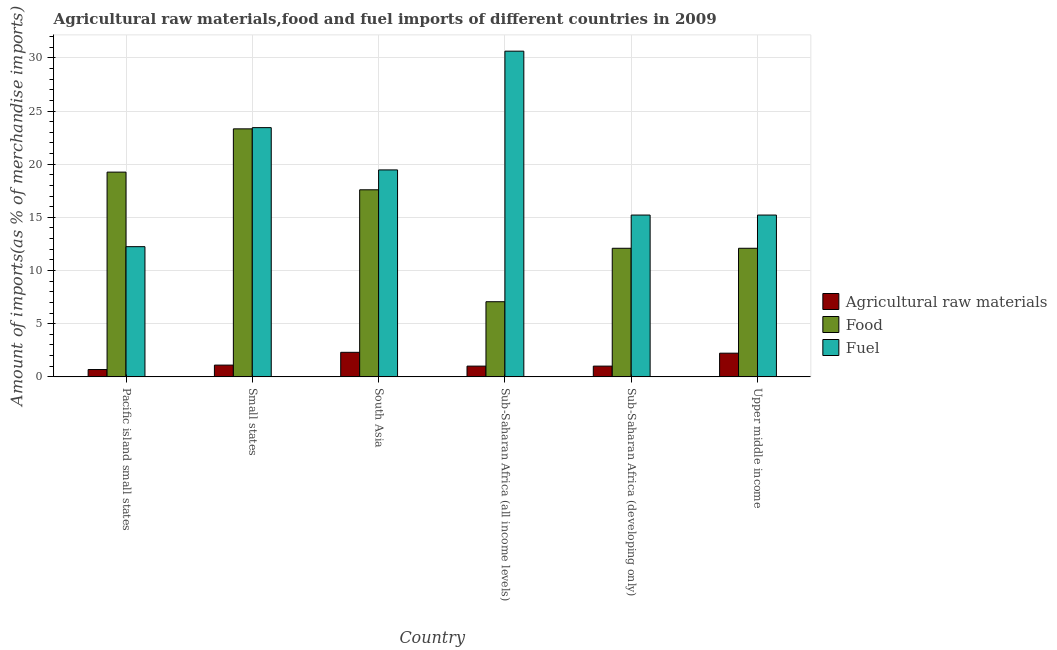How many groups of bars are there?
Offer a very short reply. 6. Are the number of bars per tick equal to the number of legend labels?
Ensure brevity in your answer.  Yes. How many bars are there on the 4th tick from the right?
Make the answer very short. 3. What is the label of the 5th group of bars from the left?
Your answer should be very brief. Sub-Saharan Africa (developing only). In how many cases, is the number of bars for a given country not equal to the number of legend labels?
Make the answer very short. 0. What is the percentage of fuel imports in Small states?
Provide a succinct answer. 23.44. Across all countries, what is the maximum percentage of fuel imports?
Your response must be concise. 30.63. Across all countries, what is the minimum percentage of fuel imports?
Keep it short and to the point. 12.24. In which country was the percentage of fuel imports maximum?
Provide a succinct answer. Sub-Saharan Africa (all income levels). In which country was the percentage of raw materials imports minimum?
Ensure brevity in your answer.  Pacific island small states. What is the total percentage of raw materials imports in the graph?
Your answer should be compact. 8.35. What is the difference between the percentage of fuel imports in Small states and that in South Asia?
Make the answer very short. 3.98. What is the difference between the percentage of raw materials imports in Small states and the percentage of food imports in Sub-Saharan Africa (developing only)?
Keep it short and to the point. -10.99. What is the average percentage of raw materials imports per country?
Provide a short and direct response. 1.39. What is the difference between the percentage of raw materials imports and percentage of food imports in Upper middle income?
Keep it short and to the point. -9.87. In how many countries, is the percentage of fuel imports greater than 24 %?
Your answer should be compact. 1. What is the ratio of the percentage of food imports in Pacific island small states to that in Upper middle income?
Give a very brief answer. 1.59. Is the percentage of food imports in Small states less than that in Sub-Saharan Africa (all income levels)?
Your response must be concise. No. Is the difference between the percentage of raw materials imports in Small states and Sub-Saharan Africa (all income levels) greater than the difference between the percentage of food imports in Small states and Sub-Saharan Africa (all income levels)?
Ensure brevity in your answer.  No. What is the difference between the highest and the second highest percentage of fuel imports?
Provide a succinct answer. 7.19. What is the difference between the highest and the lowest percentage of fuel imports?
Provide a short and direct response. 18.38. What does the 3rd bar from the left in Small states represents?
Your answer should be very brief. Fuel. What does the 2nd bar from the right in Pacific island small states represents?
Provide a succinct answer. Food. Are all the bars in the graph horizontal?
Offer a terse response. No. Are the values on the major ticks of Y-axis written in scientific E-notation?
Make the answer very short. No. Does the graph contain any zero values?
Ensure brevity in your answer.  No. Where does the legend appear in the graph?
Make the answer very short. Center right. How many legend labels are there?
Offer a very short reply. 3. How are the legend labels stacked?
Your response must be concise. Vertical. What is the title of the graph?
Ensure brevity in your answer.  Agricultural raw materials,food and fuel imports of different countries in 2009. Does "Manufactures" appear as one of the legend labels in the graph?
Your response must be concise. No. What is the label or title of the X-axis?
Ensure brevity in your answer.  Country. What is the label or title of the Y-axis?
Your response must be concise. Amount of imports(as % of merchandise imports). What is the Amount of imports(as % of merchandise imports) in Agricultural raw materials in Pacific island small states?
Your answer should be very brief. 0.69. What is the Amount of imports(as % of merchandise imports) of Food in Pacific island small states?
Offer a terse response. 19.25. What is the Amount of imports(as % of merchandise imports) in Fuel in Pacific island small states?
Provide a succinct answer. 12.24. What is the Amount of imports(as % of merchandise imports) of Agricultural raw materials in Small states?
Keep it short and to the point. 1.11. What is the Amount of imports(as % of merchandise imports) of Food in Small states?
Give a very brief answer. 23.32. What is the Amount of imports(as % of merchandise imports) in Fuel in Small states?
Keep it short and to the point. 23.44. What is the Amount of imports(as % of merchandise imports) in Agricultural raw materials in South Asia?
Your answer should be very brief. 2.31. What is the Amount of imports(as % of merchandise imports) in Food in South Asia?
Your answer should be very brief. 17.59. What is the Amount of imports(as % of merchandise imports) of Fuel in South Asia?
Your response must be concise. 19.46. What is the Amount of imports(as % of merchandise imports) of Agricultural raw materials in Sub-Saharan Africa (all income levels)?
Offer a very short reply. 1.01. What is the Amount of imports(as % of merchandise imports) in Food in Sub-Saharan Africa (all income levels)?
Provide a short and direct response. 7.07. What is the Amount of imports(as % of merchandise imports) in Fuel in Sub-Saharan Africa (all income levels)?
Keep it short and to the point. 30.63. What is the Amount of imports(as % of merchandise imports) in Agricultural raw materials in Sub-Saharan Africa (developing only)?
Offer a terse response. 1.01. What is the Amount of imports(as % of merchandise imports) in Food in Sub-Saharan Africa (developing only)?
Make the answer very short. 12.09. What is the Amount of imports(as % of merchandise imports) in Fuel in Sub-Saharan Africa (developing only)?
Your answer should be very brief. 15.22. What is the Amount of imports(as % of merchandise imports) in Agricultural raw materials in Upper middle income?
Offer a very short reply. 2.23. What is the Amount of imports(as % of merchandise imports) in Food in Upper middle income?
Your response must be concise. 12.09. What is the Amount of imports(as % of merchandise imports) in Fuel in Upper middle income?
Offer a very short reply. 15.22. Across all countries, what is the maximum Amount of imports(as % of merchandise imports) of Agricultural raw materials?
Your answer should be compact. 2.31. Across all countries, what is the maximum Amount of imports(as % of merchandise imports) of Food?
Your answer should be very brief. 23.32. Across all countries, what is the maximum Amount of imports(as % of merchandise imports) in Fuel?
Provide a short and direct response. 30.63. Across all countries, what is the minimum Amount of imports(as % of merchandise imports) of Agricultural raw materials?
Give a very brief answer. 0.69. Across all countries, what is the minimum Amount of imports(as % of merchandise imports) of Food?
Provide a succinct answer. 7.07. Across all countries, what is the minimum Amount of imports(as % of merchandise imports) of Fuel?
Give a very brief answer. 12.24. What is the total Amount of imports(as % of merchandise imports) in Agricultural raw materials in the graph?
Keep it short and to the point. 8.35. What is the total Amount of imports(as % of merchandise imports) in Food in the graph?
Make the answer very short. 91.42. What is the total Amount of imports(as % of merchandise imports) in Fuel in the graph?
Your response must be concise. 116.2. What is the difference between the Amount of imports(as % of merchandise imports) in Agricultural raw materials in Pacific island small states and that in Small states?
Your response must be concise. -0.42. What is the difference between the Amount of imports(as % of merchandise imports) of Food in Pacific island small states and that in Small states?
Give a very brief answer. -4.07. What is the difference between the Amount of imports(as % of merchandise imports) in Fuel in Pacific island small states and that in Small states?
Your answer should be very brief. -11.19. What is the difference between the Amount of imports(as % of merchandise imports) in Agricultural raw materials in Pacific island small states and that in South Asia?
Give a very brief answer. -1.62. What is the difference between the Amount of imports(as % of merchandise imports) in Food in Pacific island small states and that in South Asia?
Make the answer very short. 1.66. What is the difference between the Amount of imports(as % of merchandise imports) in Fuel in Pacific island small states and that in South Asia?
Make the answer very short. -7.22. What is the difference between the Amount of imports(as % of merchandise imports) of Agricultural raw materials in Pacific island small states and that in Sub-Saharan Africa (all income levels)?
Your response must be concise. -0.32. What is the difference between the Amount of imports(as % of merchandise imports) of Food in Pacific island small states and that in Sub-Saharan Africa (all income levels)?
Make the answer very short. 12.19. What is the difference between the Amount of imports(as % of merchandise imports) of Fuel in Pacific island small states and that in Sub-Saharan Africa (all income levels)?
Provide a short and direct response. -18.38. What is the difference between the Amount of imports(as % of merchandise imports) of Agricultural raw materials in Pacific island small states and that in Sub-Saharan Africa (developing only)?
Give a very brief answer. -0.32. What is the difference between the Amount of imports(as % of merchandise imports) in Food in Pacific island small states and that in Sub-Saharan Africa (developing only)?
Keep it short and to the point. 7.16. What is the difference between the Amount of imports(as % of merchandise imports) of Fuel in Pacific island small states and that in Sub-Saharan Africa (developing only)?
Give a very brief answer. -2.97. What is the difference between the Amount of imports(as % of merchandise imports) of Agricultural raw materials in Pacific island small states and that in Upper middle income?
Keep it short and to the point. -1.54. What is the difference between the Amount of imports(as % of merchandise imports) of Food in Pacific island small states and that in Upper middle income?
Make the answer very short. 7.16. What is the difference between the Amount of imports(as % of merchandise imports) of Fuel in Pacific island small states and that in Upper middle income?
Give a very brief answer. -2.97. What is the difference between the Amount of imports(as % of merchandise imports) in Agricultural raw materials in Small states and that in South Asia?
Offer a terse response. -1.2. What is the difference between the Amount of imports(as % of merchandise imports) in Food in Small states and that in South Asia?
Your answer should be compact. 5.73. What is the difference between the Amount of imports(as % of merchandise imports) in Fuel in Small states and that in South Asia?
Ensure brevity in your answer.  3.98. What is the difference between the Amount of imports(as % of merchandise imports) in Agricultural raw materials in Small states and that in Sub-Saharan Africa (all income levels)?
Provide a succinct answer. 0.1. What is the difference between the Amount of imports(as % of merchandise imports) in Food in Small states and that in Sub-Saharan Africa (all income levels)?
Provide a short and direct response. 16.26. What is the difference between the Amount of imports(as % of merchandise imports) of Fuel in Small states and that in Sub-Saharan Africa (all income levels)?
Your answer should be compact. -7.19. What is the difference between the Amount of imports(as % of merchandise imports) in Agricultural raw materials in Small states and that in Sub-Saharan Africa (developing only)?
Offer a very short reply. 0.1. What is the difference between the Amount of imports(as % of merchandise imports) of Food in Small states and that in Sub-Saharan Africa (developing only)?
Your response must be concise. 11.23. What is the difference between the Amount of imports(as % of merchandise imports) in Fuel in Small states and that in Sub-Saharan Africa (developing only)?
Make the answer very short. 8.22. What is the difference between the Amount of imports(as % of merchandise imports) of Agricultural raw materials in Small states and that in Upper middle income?
Make the answer very short. -1.12. What is the difference between the Amount of imports(as % of merchandise imports) in Food in Small states and that in Upper middle income?
Your answer should be compact. 11.23. What is the difference between the Amount of imports(as % of merchandise imports) in Fuel in Small states and that in Upper middle income?
Your response must be concise. 8.22. What is the difference between the Amount of imports(as % of merchandise imports) of Agricultural raw materials in South Asia and that in Sub-Saharan Africa (all income levels)?
Provide a short and direct response. 1.3. What is the difference between the Amount of imports(as % of merchandise imports) of Food in South Asia and that in Sub-Saharan Africa (all income levels)?
Give a very brief answer. 10.53. What is the difference between the Amount of imports(as % of merchandise imports) in Fuel in South Asia and that in Sub-Saharan Africa (all income levels)?
Ensure brevity in your answer.  -11.17. What is the difference between the Amount of imports(as % of merchandise imports) of Agricultural raw materials in South Asia and that in Sub-Saharan Africa (developing only)?
Offer a terse response. 1.3. What is the difference between the Amount of imports(as % of merchandise imports) of Food in South Asia and that in Sub-Saharan Africa (developing only)?
Make the answer very short. 5.5. What is the difference between the Amount of imports(as % of merchandise imports) of Fuel in South Asia and that in Sub-Saharan Africa (developing only)?
Your response must be concise. 4.25. What is the difference between the Amount of imports(as % of merchandise imports) of Agricultural raw materials in South Asia and that in Upper middle income?
Provide a succinct answer. 0.08. What is the difference between the Amount of imports(as % of merchandise imports) of Food in South Asia and that in Upper middle income?
Your response must be concise. 5.5. What is the difference between the Amount of imports(as % of merchandise imports) of Fuel in South Asia and that in Upper middle income?
Make the answer very short. 4.25. What is the difference between the Amount of imports(as % of merchandise imports) in Agricultural raw materials in Sub-Saharan Africa (all income levels) and that in Sub-Saharan Africa (developing only)?
Provide a short and direct response. 0. What is the difference between the Amount of imports(as % of merchandise imports) in Food in Sub-Saharan Africa (all income levels) and that in Sub-Saharan Africa (developing only)?
Keep it short and to the point. -5.03. What is the difference between the Amount of imports(as % of merchandise imports) of Fuel in Sub-Saharan Africa (all income levels) and that in Sub-Saharan Africa (developing only)?
Give a very brief answer. 15.41. What is the difference between the Amount of imports(as % of merchandise imports) of Agricultural raw materials in Sub-Saharan Africa (all income levels) and that in Upper middle income?
Your answer should be very brief. -1.22. What is the difference between the Amount of imports(as % of merchandise imports) of Food in Sub-Saharan Africa (all income levels) and that in Upper middle income?
Offer a terse response. -5.03. What is the difference between the Amount of imports(as % of merchandise imports) in Fuel in Sub-Saharan Africa (all income levels) and that in Upper middle income?
Give a very brief answer. 15.41. What is the difference between the Amount of imports(as % of merchandise imports) of Agricultural raw materials in Sub-Saharan Africa (developing only) and that in Upper middle income?
Make the answer very short. -1.22. What is the difference between the Amount of imports(as % of merchandise imports) in Fuel in Sub-Saharan Africa (developing only) and that in Upper middle income?
Offer a very short reply. 0. What is the difference between the Amount of imports(as % of merchandise imports) of Agricultural raw materials in Pacific island small states and the Amount of imports(as % of merchandise imports) of Food in Small states?
Provide a succinct answer. -22.63. What is the difference between the Amount of imports(as % of merchandise imports) of Agricultural raw materials in Pacific island small states and the Amount of imports(as % of merchandise imports) of Fuel in Small states?
Provide a succinct answer. -22.75. What is the difference between the Amount of imports(as % of merchandise imports) in Food in Pacific island small states and the Amount of imports(as % of merchandise imports) in Fuel in Small states?
Provide a succinct answer. -4.18. What is the difference between the Amount of imports(as % of merchandise imports) in Agricultural raw materials in Pacific island small states and the Amount of imports(as % of merchandise imports) in Food in South Asia?
Keep it short and to the point. -16.9. What is the difference between the Amount of imports(as % of merchandise imports) of Agricultural raw materials in Pacific island small states and the Amount of imports(as % of merchandise imports) of Fuel in South Asia?
Your answer should be very brief. -18.77. What is the difference between the Amount of imports(as % of merchandise imports) in Food in Pacific island small states and the Amount of imports(as % of merchandise imports) in Fuel in South Asia?
Keep it short and to the point. -0.21. What is the difference between the Amount of imports(as % of merchandise imports) in Agricultural raw materials in Pacific island small states and the Amount of imports(as % of merchandise imports) in Food in Sub-Saharan Africa (all income levels)?
Your answer should be very brief. -6.38. What is the difference between the Amount of imports(as % of merchandise imports) in Agricultural raw materials in Pacific island small states and the Amount of imports(as % of merchandise imports) in Fuel in Sub-Saharan Africa (all income levels)?
Keep it short and to the point. -29.94. What is the difference between the Amount of imports(as % of merchandise imports) in Food in Pacific island small states and the Amount of imports(as % of merchandise imports) in Fuel in Sub-Saharan Africa (all income levels)?
Provide a succinct answer. -11.37. What is the difference between the Amount of imports(as % of merchandise imports) of Agricultural raw materials in Pacific island small states and the Amount of imports(as % of merchandise imports) of Food in Sub-Saharan Africa (developing only)?
Your answer should be compact. -11.4. What is the difference between the Amount of imports(as % of merchandise imports) of Agricultural raw materials in Pacific island small states and the Amount of imports(as % of merchandise imports) of Fuel in Sub-Saharan Africa (developing only)?
Keep it short and to the point. -14.53. What is the difference between the Amount of imports(as % of merchandise imports) of Food in Pacific island small states and the Amount of imports(as % of merchandise imports) of Fuel in Sub-Saharan Africa (developing only)?
Your response must be concise. 4.04. What is the difference between the Amount of imports(as % of merchandise imports) of Agricultural raw materials in Pacific island small states and the Amount of imports(as % of merchandise imports) of Food in Upper middle income?
Your response must be concise. -11.4. What is the difference between the Amount of imports(as % of merchandise imports) of Agricultural raw materials in Pacific island small states and the Amount of imports(as % of merchandise imports) of Fuel in Upper middle income?
Provide a succinct answer. -14.53. What is the difference between the Amount of imports(as % of merchandise imports) of Food in Pacific island small states and the Amount of imports(as % of merchandise imports) of Fuel in Upper middle income?
Ensure brevity in your answer.  4.04. What is the difference between the Amount of imports(as % of merchandise imports) in Agricultural raw materials in Small states and the Amount of imports(as % of merchandise imports) in Food in South Asia?
Provide a short and direct response. -16.49. What is the difference between the Amount of imports(as % of merchandise imports) of Agricultural raw materials in Small states and the Amount of imports(as % of merchandise imports) of Fuel in South Asia?
Give a very brief answer. -18.35. What is the difference between the Amount of imports(as % of merchandise imports) of Food in Small states and the Amount of imports(as % of merchandise imports) of Fuel in South Asia?
Offer a terse response. 3.86. What is the difference between the Amount of imports(as % of merchandise imports) of Agricultural raw materials in Small states and the Amount of imports(as % of merchandise imports) of Food in Sub-Saharan Africa (all income levels)?
Offer a very short reply. -5.96. What is the difference between the Amount of imports(as % of merchandise imports) of Agricultural raw materials in Small states and the Amount of imports(as % of merchandise imports) of Fuel in Sub-Saharan Africa (all income levels)?
Make the answer very short. -29.52. What is the difference between the Amount of imports(as % of merchandise imports) in Food in Small states and the Amount of imports(as % of merchandise imports) in Fuel in Sub-Saharan Africa (all income levels)?
Offer a terse response. -7.31. What is the difference between the Amount of imports(as % of merchandise imports) in Agricultural raw materials in Small states and the Amount of imports(as % of merchandise imports) in Food in Sub-Saharan Africa (developing only)?
Keep it short and to the point. -10.99. What is the difference between the Amount of imports(as % of merchandise imports) in Agricultural raw materials in Small states and the Amount of imports(as % of merchandise imports) in Fuel in Sub-Saharan Africa (developing only)?
Offer a terse response. -14.11. What is the difference between the Amount of imports(as % of merchandise imports) in Food in Small states and the Amount of imports(as % of merchandise imports) in Fuel in Sub-Saharan Africa (developing only)?
Make the answer very short. 8.11. What is the difference between the Amount of imports(as % of merchandise imports) of Agricultural raw materials in Small states and the Amount of imports(as % of merchandise imports) of Food in Upper middle income?
Ensure brevity in your answer.  -10.99. What is the difference between the Amount of imports(as % of merchandise imports) of Agricultural raw materials in Small states and the Amount of imports(as % of merchandise imports) of Fuel in Upper middle income?
Your response must be concise. -14.11. What is the difference between the Amount of imports(as % of merchandise imports) of Food in Small states and the Amount of imports(as % of merchandise imports) of Fuel in Upper middle income?
Your response must be concise. 8.11. What is the difference between the Amount of imports(as % of merchandise imports) in Agricultural raw materials in South Asia and the Amount of imports(as % of merchandise imports) in Food in Sub-Saharan Africa (all income levels)?
Give a very brief answer. -4.76. What is the difference between the Amount of imports(as % of merchandise imports) of Agricultural raw materials in South Asia and the Amount of imports(as % of merchandise imports) of Fuel in Sub-Saharan Africa (all income levels)?
Provide a short and direct response. -28.32. What is the difference between the Amount of imports(as % of merchandise imports) of Food in South Asia and the Amount of imports(as % of merchandise imports) of Fuel in Sub-Saharan Africa (all income levels)?
Your answer should be very brief. -13.04. What is the difference between the Amount of imports(as % of merchandise imports) of Agricultural raw materials in South Asia and the Amount of imports(as % of merchandise imports) of Food in Sub-Saharan Africa (developing only)?
Ensure brevity in your answer.  -9.78. What is the difference between the Amount of imports(as % of merchandise imports) of Agricultural raw materials in South Asia and the Amount of imports(as % of merchandise imports) of Fuel in Sub-Saharan Africa (developing only)?
Provide a succinct answer. -12.91. What is the difference between the Amount of imports(as % of merchandise imports) in Food in South Asia and the Amount of imports(as % of merchandise imports) in Fuel in Sub-Saharan Africa (developing only)?
Ensure brevity in your answer.  2.38. What is the difference between the Amount of imports(as % of merchandise imports) in Agricultural raw materials in South Asia and the Amount of imports(as % of merchandise imports) in Food in Upper middle income?
Provide a short and direct response. -9.78. What is the difference between the Amount of imports(as % of merchandise imports) of Agricultural raw materials in South Asia and the Amount of imports(as % of merchandise imports) of Fuel in Upper middle income?
Offer a very short reply. -12.91. What is the difference between the Amount of imports(as % of merchandise imports) of Food in South Asia and the Amount of imports(as % of merchandise imports) of Fuel in Upper middle income?
Offer a terse response. 2.38. What is the difference between the Amount of imports(as % of merchandise imports) in Agricultural raw materials in Sub-Saharan Africa (all income levels) and the Amount of imports(as % of merchandise imports) in Food in Sub-Saharan Africa (developing only)?
Provide a short and direct response. -11.08. What is the difference between the Amount of imports(as % of merchandise imports) of Agricultural raw materials in Sub-Saharan Africa (all income levels) and the Amount of imports(as % of merchandise imports) of Fuel in Sub-Saharan Africa (developing only)?
Your answer should be very brief. -14.21. What is the difference between the Amount of imports(as % of merchandise imports) of Food in Sub-Saharan Africa (all income levels) and the Amount of imports(as % of merchandise imports) of Fuel in Sub-Saharan Africa (developing only)?
Keep it short and to the point. -8.15. What is the difference between the Amount of imports(as % of merchandise imports) in Agricultural raw materials in Sub-Saharan Africa (all income levels) and the Amount of imports(as % of merchandise imports) in Food in Upper middle income?
Ensure brevity in your answer.  -11.08. What is the difference between the Amount of imports(as % of merchandise imports) of Agricultural raw materials in Sub-Saharan Africa (all income levels) and the Amount of imports(as % of merchandise imports) of Fuel in Upper middle income?
Offer a terse response. -14.21. What is the difference between the Amount of imports(as % of merchandise imports) in Food in Sub-Saharan Africa (all income levels) and the Amount of imports(as % of merchandise imports) in Fuel in Upper middle income?
Make the answer very short. -8.15. What is the difference between the Amount of imports(as % of merchandise imports) of Agricultural raw materials in Sub-Saharan Africa (developing only) and the Amount of imports(as % of merchandise imports) of Food in Upper middle income?
Your answer should be compact. -11.08. What is the difference between the Amount of imports(as % of merchandise imports) of Agricultural raw materials in Sub-Saharan Africa (developing only) and the Amount of imports(as % of merchandise imports) of Fuel in Upper middle income?
Ensure brevity in your answer.  -14.21. What is the difference between the Amount of imports(as % of merchandise imports) in Food in Sub-Saharan Africa (developing only) and the Amount of imports(as % of merchandise imports) in Fuel in Upper middle income?
Keep it short and to the point. -3.12. What is the average Amount of imports(as % of merchandise imports) in Agricultural raw materials per country?
Offer a terse response. 1.39. What is the average Amount of imports(as % of merchandise imports) in Food per country?
Ensure brevity in your answer.  15.24. What is the average Amount of imports(as % of merchandise imports) in Fuel per country?
Ensure brevity in your answer.  19.37. What is the difference between the Amount of imports(as % of merchandise imports) in Agricultural raw materials and Amount of imports(as % of merchandise imports) in Food in Pacific island small states?
Ensure brevity in your answer.  -18.57. What is the difference between the Amount of imports(as % of merchandise imports) of Agricultural raw materials and Amount of imports(as % of merchandise imports) of Fuel in Pacific island small states?
Make the answer very short. -11.55. What is the difference between the Amount of imports(as % of merchandise imports) of Food and Amount of imports(as % of merchandise imports) of Fuel in Pacific island small states?
Give a very brief answer. 7.01. What is the difference between the Amount of imports(as % of merchandise imports) in Agricultural raw materials and Amount of imports(as % of merchandise imports) in Food in Small states?
Your answer should be very brief. -22.22. What is the difference between the Amount of imports(as % of merchandise imports) of Agricultural raw materials and Amount of imports(as % of merchandise imports) of Fuel in Small states?
Your response must be concise. -22.33. What is the difference between the Amount of imports(as % of merchandise imports) of Food and Amount of imports(as % of merchandise imports) of Fuel in Small states?
Give a very brief answer. -0.11. What is the difference between the Amount of imports(as % of merchandise imports) of Agricultural raw materials and Amount of imports(as % of merchandise imports) of Food in South Asia?
Provide a short and direct response. -15.28. What is the difference between the Amount of imports(as % of merchandise imports) in Agricultural raw materials and Amount of imports(as % of merchandise imports) in Fuel in South Asia?
Keep it short and to the point. -17.15. What is the difference between the Amount of imports(as % of merchandise imports) of Food and Amount of imports(as % of merchandise imports) of Fuel in South Asia?
Give a very brief answer. -1.87. What is the difference between the Amount of imports(as % of merchandise imports) in Agricultural raw materials and Amount of imports(as % of merchandise imports) in Food in Sub-Saharan Africa (all income levels)?
Keep it short and to the point. -6.06. What is the difference between the Amount of imports(as % of merchandise imports) in Agricultural raw materials and Amount of imports(as % of merchandise imports) in Fuel in Sub-Saharan Africa (all income levels)?
Provide a succinct answer. -29.62. What is the difference between the Amount of imports(as % of merchandise imports) of Food and Amount of imports(as % of merchandise imports) of Fuel in Sub-Saharan Africa (all income levels)?
Offer a very short reply. -23.56. What is the difference between the Amount of imports(as % of merchandise imports) in Agricultural raw materials and Amount of imports(as % of merchandise imports) in Food in Sub-Saharan Africa (developing only)?
Give a very brief answer. -11.08. What is the difference between the Amount of imports(as % of merchandise imports) in Agricultural raw materials and Amount of imports(as % of merchandise imports) in Fuel in Sub-Saharan Africa (developing only)?
Keep it short and to the point. -14.21. What is the difference between the Amount of imports(as % of merchandise imports) in Food and Amount of imports(as % of merchandise imports) in Fuel in Sub-Saharan Africa (developing only)?
Ensure brevity in your answer.  -3.12. What is the difference between the Amount of imports(as % of merchandise imports) of Agricultural raw materials and Amount of imports(as % of merchandise imports) of Food in Upper middle income?
Your response must be concise. -9.87. What is the difference between the Amount of imports(as % of merchandise imports) in Agricultural raw materials and Amount of imports(as % of merchandise imports) in Fuel in Upper middle income?
Your response must be concise. -12.99. What is the difference between the Amount of imports(as % of merchandise imports) in Food and Amount of imports(as % of merchandise imports) in Fuel in Upper middle income?
Keep it short and to the point. -3.12. What is the ratio of the Amount of imports(as % of merchandise imports) in Agricultural raw materials in Pacific island small states to that in Small states?
Offer a very short reply. 0.62. What is the ratio of the Amount of imports(as % of merchandise imports) of Food in Pacific island small states to that in Small states?
Offer a terse response. 0.83. What is the ratio of the Amount of imports(as % of merchandise imports) in Fuel in Pacific island small states to that in Small states?
Make the answer very short. 0.52. What is the ratio of the Amount of imports(as % of merchandise imports) in Agricultural raw materials in Pacific island small states to that in South Asia?
Make the answer very short. 0.3. What is the ratio of the Amount of imports(as % of merchandise imports) of Food in Pacific island small states to that in South Asia?
Provide a succinct answer. 1.09. What is the ratio of the Amount of imports(as % of merchandise imports) of Fuel in Pacific island small states to that in South Asia?
Give a very brief answer. 0.63. What is the ratio of the Amount of imports(as % of merchandise imports) in Agricultural raw materials in Pacific island small states to that in Sub-Saharan Africa (all income levels)?
Your answer should be compact. 0.68. What is the ratio of the Amount of imports(as % of merchandise imports) in Food in Pacific island small states to that in Sub-Saharan Africa (all income levels)?
Provide a succinct answer. 2.72. What is the ratio of the Amount of imports(as % of merchandise imports) of Fuel in Pacific island small states to that in Sub-Saharan Africa (all income levels)?
Give a very brief answer. 0.4. What is the ratio of the Amount of imports(as % of merchandise imports) in Agricultural raw materials in Pacific island small states to that in Sub-Saharan Africa (developing only)?
Your answer should be very brief. 0.68. What is the ratio of the Amount of imports(as % of merchandise imports) in Food in Pacific island small states to that in Sub-Saharan Africa (developing only)?
Give a very brief answer. 1.59. What is the ratio of the Amount of imports(as % of merchandise imports) in Fuel in Pacific island small states to that in Sub-Saharan Africa (developing only)?
Your answer should be compact. 0.8. What is the ratio of the Amount of imports(as % of merchandise imports) in Agricultural raw materials in Pacific island small states to that in Upper middle income?
Keep it short and to the point. 0.31. What is the ratio of the Amount of imports(as % of merchandise imports) of Food in Pacific island small states to that in Upper middle income?
Offer a very short reply. 1.59. What is the ratio of the Amount of imports(as % of merchandise imports) of Fuel in Pacific island small states to that in Upper middle income?
Your response must be concise. 0.8. What is the ratio of the Amount of imports(as % of merchandise imports) of Agricultural raw materials in Small states to that in South Asia?
Your response must be concise. 0.48. What is the ratio of the Amount of imports(as % of merchandise imports) of Food in Small states to that in South Asia?
Your answer should be compact. 1.33. What is the ratio of the Amount of imports(as % of merchandise imports) in Fuel in Small states to that in South Asia?
Your answer should be very brief. 1.2. What is the ratio of the Amount of imports(as % of merchandise imports) in Agricultural raw materials in Small states to that in Sub-Saharan Africa (all income levels)?
Provide a short and direct response. 1.09. What is the ratio of the Amount of imports(as % of merchandise imports) in Food in Small states to that in Sub-Saharan Africa (all income levels)?
Your answer should be very brief. 3.3. What is the ratio of the Amount of imports(as % of merchandise imports) of Fuel in Small states to that in Sub-Saharan Africa (all income levels)?
Your answer should be compact. 0.77. What is the ratio of the Amount of imports(as % of merchandise imports) in Agricultural raw materials in Small states to that in Sub-Saharan Africa (developing only)?
Provide a succinct answer. 1.09. What is the ratio of the Amount of imports(as % of merchandise imports) in Food in Small states to that in Sub-Saharan Africa (developing only)?
Offer a very short reply. 1.93. What is the ratio of the Amount of imports(as % of merchandise imports) in Fuel in Small states to that in Sub-Saharan Africa (developing only)?
Keep it short and to the point. 1.54. What is the ratio of the Amount of imports(as % of merchandise imports) of Agricultural raw materials in Small states to that in Upper middle income?
Provide a short and direct response. 0.5. What is the ratio of the Amount of imports(as % of merchandise imports) in Food in Small states to that in Upper middle income?
Your answer should be compact. 1.93. What is the ratio of the Amount of imports(as % of merchandise imports) of Fuel in Small states to that in Upper middle income?
Your response must be concise. 1.54. What is the ratio of the Amount of imports(as % of merchandise imports) in Agricultural raw materials in South Asia to that in Sub-Saharan Africa (all income levels)?
Your answer should be very brief. 2.28. What is the ratio of the Amount of imports(as % of merchandise imports) of Food in South Asia to that in Sub-Saharan Africa (all income levels)?
Your answer should be compact. 2.49. What is the ratio of the Amount of imports(as % of merchandise imports) of Fuel in South Asia to that in Sub-Saharan Africa (all income levels)?
Provide a short and direct response. 0.64. What is the ratio of the Amount of imports(as % of merchandise imports) in Agricultural raw materials in South Asia to that in Sub-Saharan Africa (developing only)?
Keep it short and to the point. 2.28. What is the ratio of the Amount of imports(as % of merchandise imports) of Food in South Asia to that in Sub-Saharan Africa (developing only)?
Your answer should be compact. 1.45. What is the ratio of the Amount of imports(as % of merchandise imports) of Fuel in South Asia to that in Sub-Saharan Africa (developing only)?
Keep it short and to the point. 1.28. What is the ratio of the Amount of imports(as % of merchandise imports) of Agricultural raw materials in South Asia to that in Upper middle income?
Keep it short and to the point. 1.04. What is the ratio of the Amount of imports(as % of merchandise imports) in Food in South Asia to that in Upper middle income?
Your answer should be very brief. 1.45. What is the ratio of the Amount of imports(as % of merchandise imports) in Fuel in South Asia to that in Upper middle income?
Provide a short and direct response. 1.28. What is the ratio of the Amount of imports(as % of merchandise imports) of Agricultural raw materials in Sub-Saharan Africa (all income levels) to that in Sub-Saharan Africa (developing only)?
Keep it short and to the point. 1. What is the ratio of the Amount of imports(as % of merchandise imports) in Food in Sub-Saharan Africa (all income levels) to that in Sub-Saharan Africa (developing only)?
Ensure brevity in your answer.  0.58. What is the ratio of the Amount of imports(as % of merchandise imports) in Fuel in Sub-Saharan Africa (all income levels) to that in Sub-Saharan Africa (developing only)?
Your response must be concise. 2.01. What is the ratio of the Amount of imports(as % of merchandise imports) in Agricultural raw materials in Sub-Saharan Africa (all income levels) to that in Upper middle income?
Give a very brief answer. 0.45. What is the ratio of the Amount of imports(as % of merchandise imports) in Food in Sub-Saharan Africa (all income levels) to that in Upper middle income?
Your response must be concise. 0.58. What is the ratio of the Amount of imports(as % of merchandise imports) of Fuel in Sub-Saharan Africa (all income levels) to that in Upper middle income?
Offer a very short reply. 2.01. What is the ratio of the Amount of imports(as % of merchandise imports) in Agricultural raw materials in Sub-Saharan Africa (developing only) to that in Upper middle income?
Ensure brevity in your answer.  0.45. What is the ratio of the Amount of imports(as % of merchandise imports) in Food in Sub-Saharan Africa (developing only) to that in Upper middle income?
Offer a very short reply. 1. What is the ratio of the Amount of imports(as % of merchandise imports) of Fuel in Sub-Saharan Africa (developing only) to that in Upper middle income?
Keep it short and to the point. 1. What is the difference between the highest and the second highest Amount of imports(as % of merchandise imports) in Agricultural raw materials?
Offer a very short reply. 0.08. What is the difference between the highest and the second highest Amount of imports(as % of merchandise imports) of Food?
Offer a terse response. 4.07. What is the difference between the highest and the second highest Amount of imports(as % of merchandise imports) of Fuel?
Your answer should be compact. 7.19. What is the difference between the highest and the lowest Amount of imports(as % of merchandise imports) of Agricultural raw materials?
Keep it short and to the point. 1.62. What is the difference between the highest and the lowest Amount of imports(as % of merchandise imports) in Food?
Ensure brevity in your answer.  16.26. What is the difference between the highest and the lowest Amount of imports(as % of merchandise imports) in Fuel?
Keep it short and to the point. 18.38. 